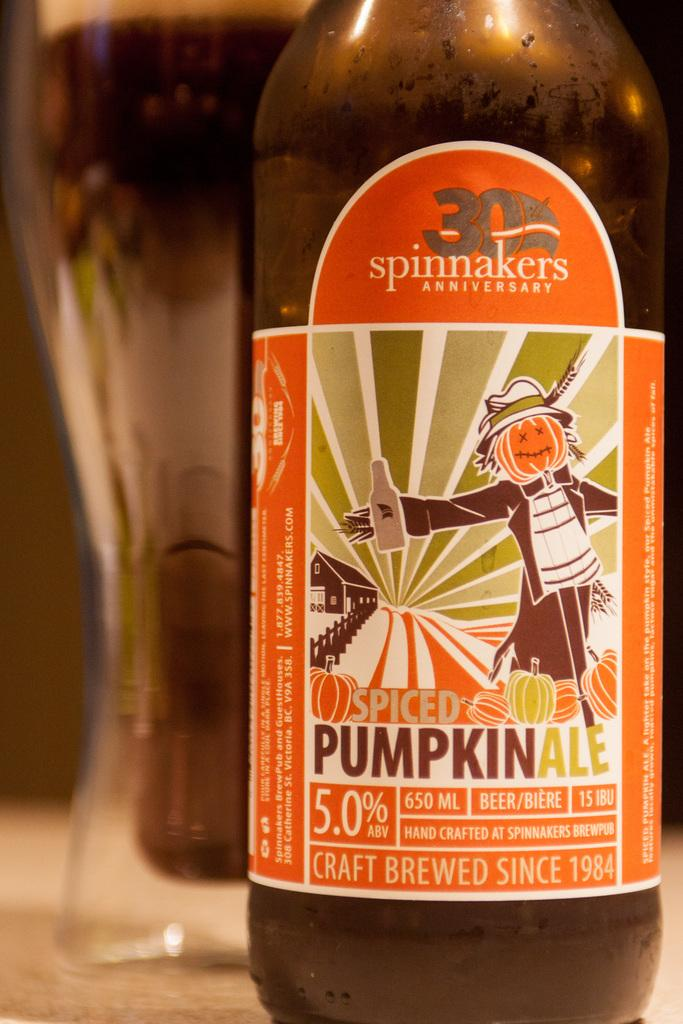Provide a one-sentence caption for the provided image. Spinnakers anniversary spiced pumpkin craft brewed beer is delicious in a glass. 